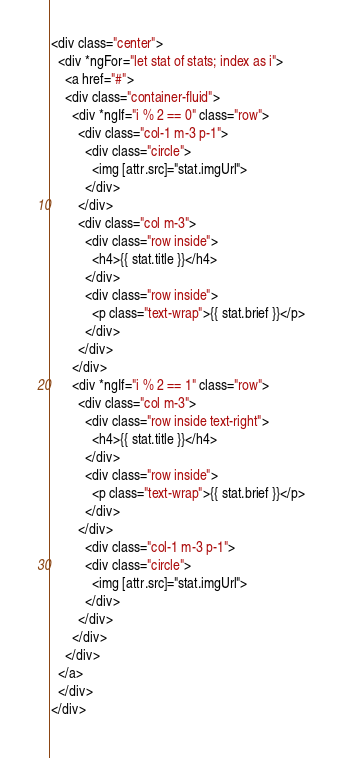Convert code to text. <code><loc_0><loc_0><loc_500><loc_500><_HTML_><div class="center">
  <div *ngFor="let stat of stats; index as i">
    <a href="#">
    <div class="container-fluid">
      <div *ngIf="i % 2 == 0" class="row">
        <div class="col-1 m-3 p-1">
          <div class="circle">
            <img [attr.src]="stat.imgUrl">
          </div>
        </div>
        <div class="col m-3">
          <div class="row inside">
            <h4>{{ stat.title }}</h4>
          </div>
          <div class="row inside">
            <p class="text-wrap">{{ stat.brief }}</p>
          </div>
        </div>
      </div>
      <div *ngIf="i % 2 == 1" class="row">
        <div class="col m-3">
          <div class="row inside text-right">
            <h4>{{ stat.title }}</h4>
          </div>
          <div class="row inside">
            <p class="text-wrap">{{ stat.brief }}</p>
          </div>
        </div>
          <div class="col-1 m-3 p-1">
          <div class="circle">
            <img [attr.src]="stat.imgUrl">
          </div>
        </div>
      </div>
    </div>
  </a>
  </div>
</div>
</code> 